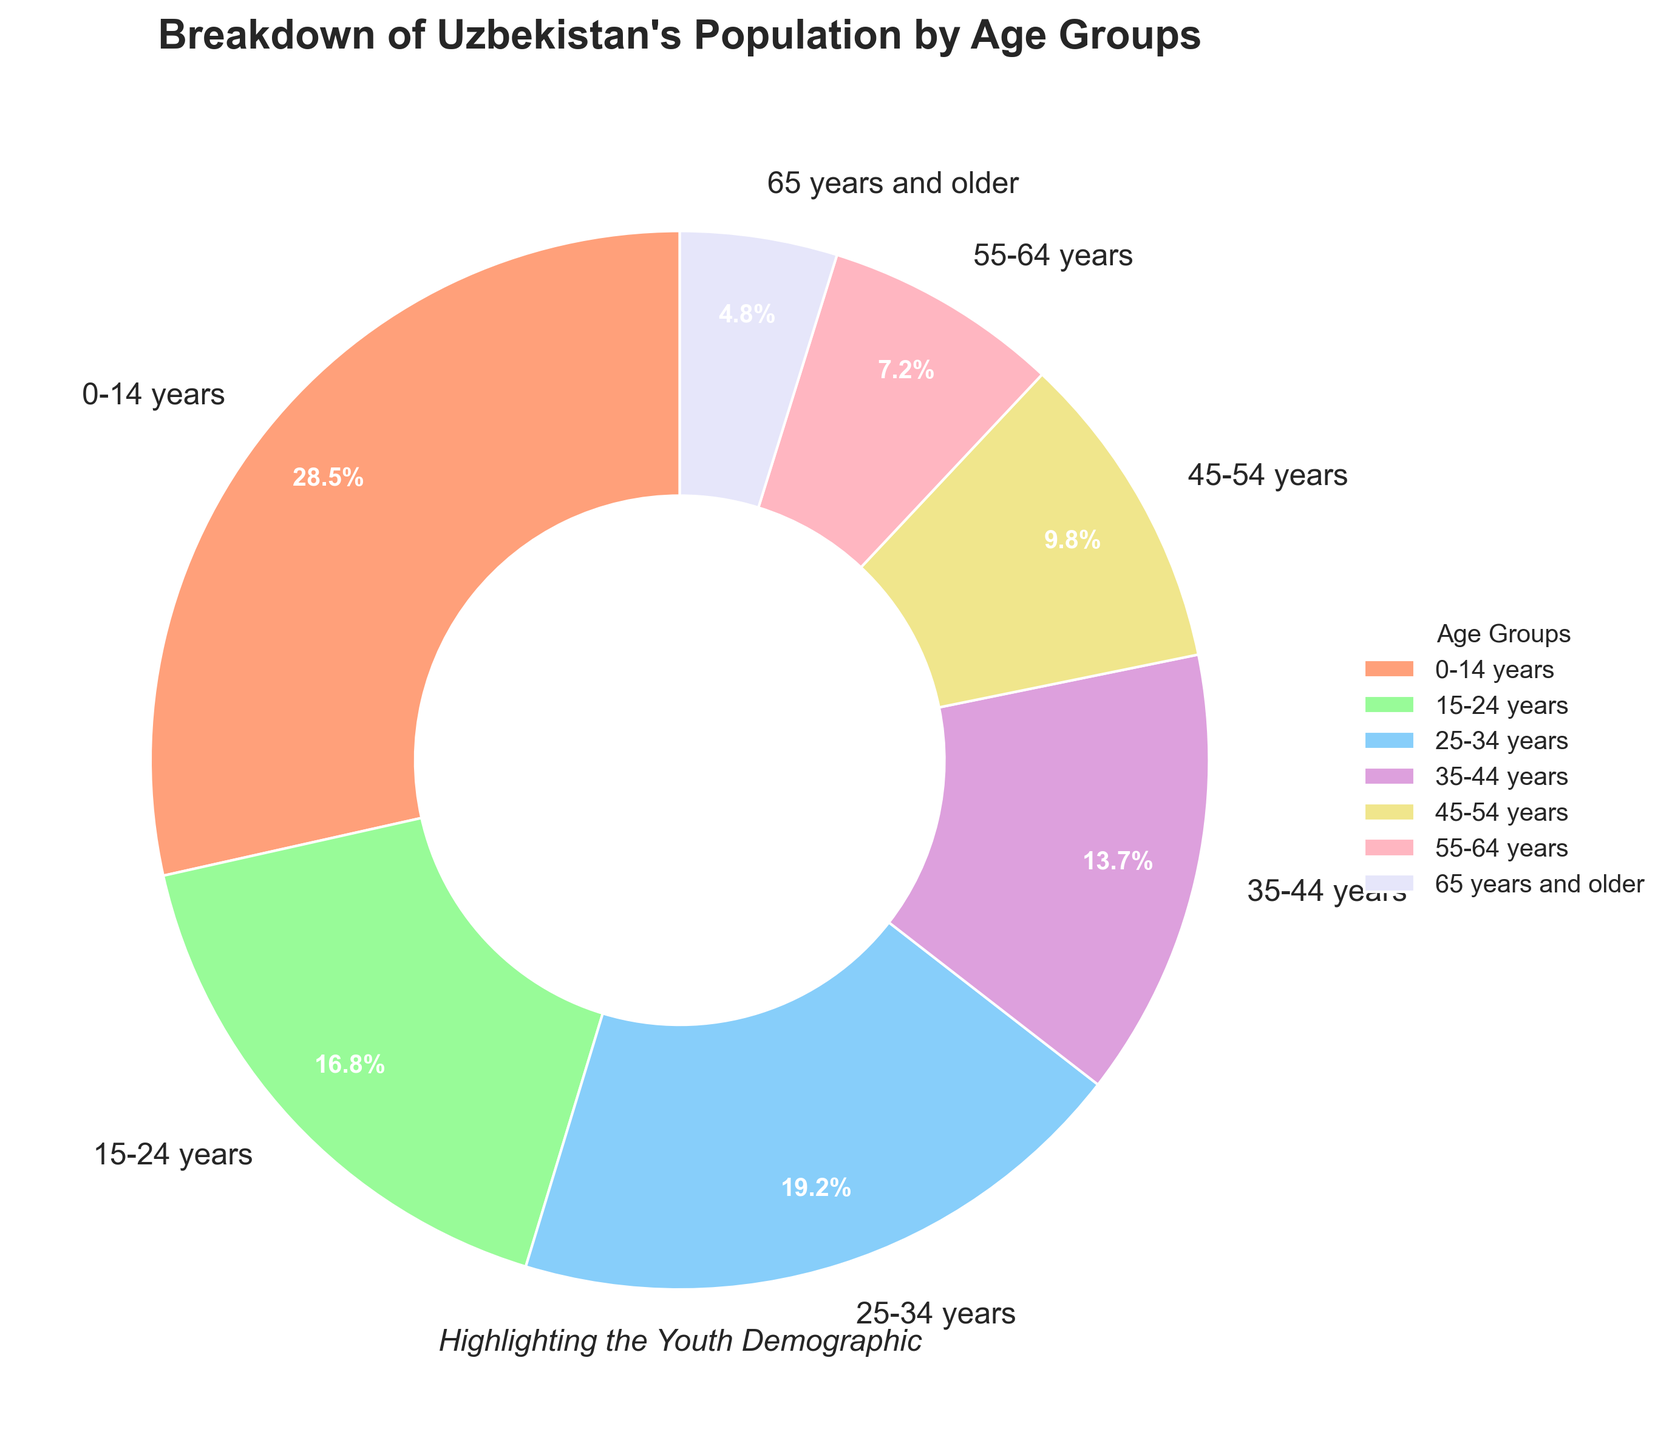What percentage of Uzbekistan's population is under 25 years old? To calculate the total percentage of the population under 25 years, we need to sum the percentages of the age groups 0-14 years (28.5%) and 15-24 years (16.8%). Adding these two values gives us 28.5 + 16.8 = 45.3%.
Answer: 45.3% What is the combined percentage of the population aged 45 years and older? To find the combined percentage of the population aged 45 years and older, we sum the percentages of the age groups 45-54 years (9.8%), 55-64 years (7.2%), and 65 years and older (4.8%). Adding these values gives us 9.8 + 7.2 + 4.8 = 21.8%.
Answer: 21.8% Which age group has the highest representation in Uzbekistan's population? By examining the pie chart, the age group with the largest wedge (and the highest percentage) is 0-14 years with 28.5%.
Answer: 0-14 years How much larger is the 0-14 years age group compared to the 65 years and older group? To find how much larger the 0-14 years age group is compared to the 65 years and older group, we subtract the percentage of the 65 years and older group (4.8%) from the percentage of the 0-14 years group (28.5%). The difference is 28.5 - 4.8 = 23.7%.
Answer: 23.7% Which age group appears in green on the pie chart, and what is its percentage? By looking at the colors described, the age group colored green is 15-24 years, which has a percentage of 16.8%.
Answer: 15-24 years, 16.8% What is the average percentage of the age groups from 25-34 years and 35-44 years? To find the average percentage, we add the percentages of the 25-34 years (19.2%) and 35-44 years (13.7%) groups, then divide by 2. The calculation is (19.2 + 13.7) / 2 = 16.45%.
Answer: 16.45% Do the age groups 55 years and older collectively make up a greater percentage than the 25-34 years group alone? First, sum the percentages of the 55-64 years (7.2%) and 65 years and older (4.8%) groups to get 7.2 + 4.8 = 12%. Then, compare this sum to the 25-34 years group percentage (19.2%). Since 12% is less than 19.2%, the 55 years and older groups collectively make up a smaller percentage.
Answer: No What's the total percentage represented by the middle age groups (25-54 years)? Sum the percentages of the 25-34 years (19.2%), 35-44 years (13.7%), and 45-54 years (9.8%) groups. The calculation is 19.2 + 13.7 + 9.8 = 42.7%.
Answer: 42.7% 